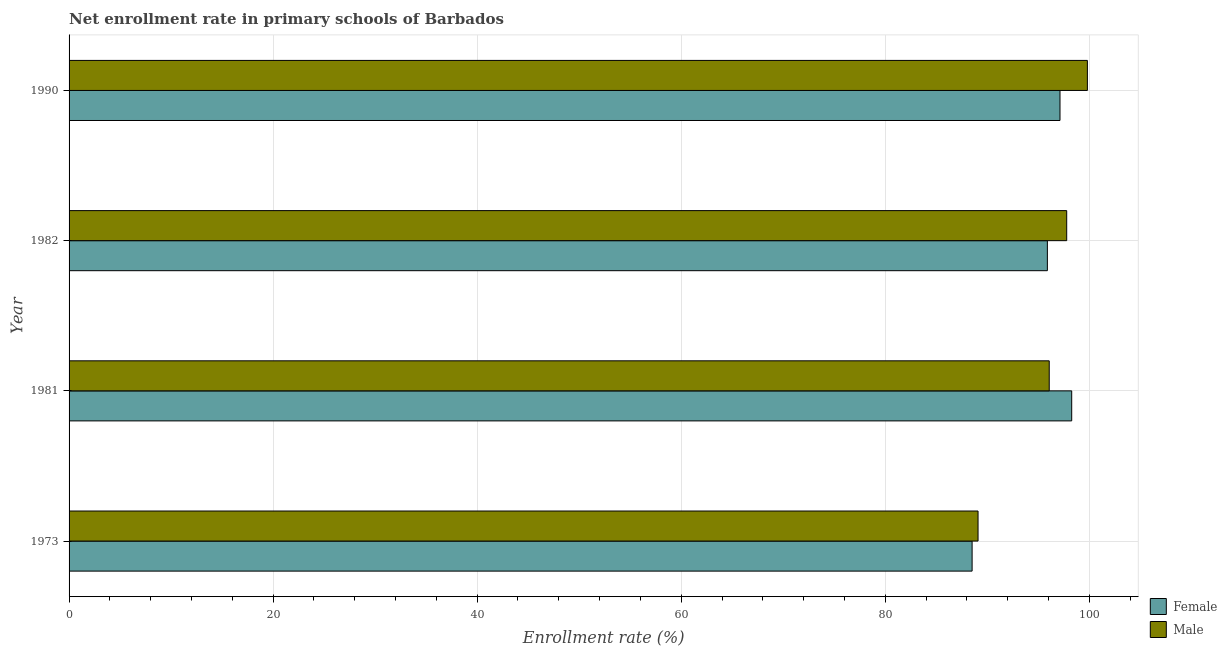Are the number of bars per tick equal to the number of legend labels?
Offer a very short reply. Yes. How many bars are there on the 2nd tick from the top?
Make the answer very short. 2. In how many cases, is the number of bars for a given year not equal to the number of legend labels?
Offer a terse response. 0. What is the enrollment rate of female students in 1973?
Keep it short and to the point. 88.52. Across all years, what is the maximum enrollment rate of female students?
Offer a terse response. 98.28. Across all years, what is the minimum enrollment rate of female students?
Offer a very short reply. 88.52. In which year was the enrollment rate of female students maximum?
Offer a very short reply. 1981. In which year was the enrollment rate of female students minimum?
Ensure brevity in your answer.  1973. What is the total enrollment rate of female students in the graph?
Provide a short and direct response. 379.82. What is the difference between the enrollment rate of female students in 1973 and that in 1982?
Your answer should be very brief. -7.38. What is the difference between the enrollment rate of female students in 1981 and the enrollment rate of male students in 1982?
Make the answer very short. 0.49. What is the average enrollment rate of female students per year?
Give a very brief answer. 94.95. In the year 1973, what is the difference between the enrollment rate of male students and enrollment rate of female students?
Provide a succinct answer. 0.58. In how many years, is the enrollment rate of female students greater than 40 %?
Your response must be concise. 4. Is the enrollment rate of female students in 1981 less than that in 1982?
Your answer should be very brief. No. What is the difference between the highest and the second highest enrollment rate of female students?
Offer a terse response. 1.15. What is the difference between the highest and the lowest enrollment rate of male students?
Offer a very short reply. 10.72. What does the 1st bar from the top in 1982 represents?
Provide a succinct answer. Male. What does the 1st bar from the bottom in 1973 represents?
Offer a very short reply. Female. How many bars are there?
Give a very brief answer. 8. Are all the bars in the graph horizontal?
Offer a terse response. Yes. Are the values on the major ticks of X-axis written in scientific E-notation?
Provide a succinct answer. No. Does the graph contain grids?
Make the answer very short. Yes. How many legend labels are there?
Your response must be concise. 2. How are the legend labels stacked?
Ensure brevity in your answer.  Vertical. What is the title of the graph?
Provide a short and direct response. Net enrollment rate in primary schools of Barbados. What is the label or title of the X-axis?
Your response must be concise. Enrollment rate (%). What is the label or title of the Y-axis?
Ensure brevity in your answer.  Year. What is the Enrollment rate (%) of Female in 1973?
Provide a short and direct response. 88.52. What is the Enrollment rate (%) in Male in 1973?
Offer a very short reply. 89.1. What is the Enrollment rate (%) in Female in 1981?
Your answer should be very brief. 98.28. What is the Enrollment rate (%) in Male in 1981?
Make the answer very short. 96.08. What is the Enrollment rate (%) of Female in 1982?
Your answer should be compact. 95.89. What is the Enrollment rate (%) of Male in 1982?
Your answer should be very brief. 97.79. What is the Enrollment rate (%) of Female in 1990?
Your answer should be very brief. 97.13. What is the Enrollment rate (%) in Male in 1990?
Offer a very short reply. 99.82. Across all years, what is the maximum Enrollment rate (%) in Female?
Your answer should be compact. 98.28. Across all years, what is the maximum Enrollment rate (%) of Male?
Provide a succinct answer. 99.82. Across all years, what is the minimum Enrollment rate (%) in Female?
Your response must be concise. 88.52. Across all years, what is the minimum Enrollment rate (%) of Male?
Give a very brief answer. 89.1. What is the total Enrollment rate (%) of Female in the graph?
Offer a very short reply. 379.82. What is the total Enrollment rate (%) in Male in the graph?
Your answer should be very brief. 382.78. What is the difference between the Enrollment rate (%) in Female in 1973 and that in 1981?
Make the answer very short. -9.76. What is the difference between the Enrollment rate (%) of Male in 1973 and that in 1981?
Keep it short and to the point. -6.98. What is the difference between the Enrollment rate (%) in Female in 1973 and that in 1982?
Give a very brief answer. -7.38. What is the difference between the Enrollment rate (%) in Male in 1973 and that in 1982?
Provide a succinct answer. -8.69. What is the difference between the Enrollment rate (%) of Female in 1973 and that in 1990?
Your answer should be compact. -8.62. What is the difference between the Enrollment rate (%) in Male in 1973 and that in 1990?
Make the answer very short. -10.72. What is the difference between the Enrollment rate (%) in Female in 1981 and that in 1982?
Keep it short and to the point. 2.38. What is the difference between the Enrollment rate (%) of Male in 1981 and that in 1982?
Provide a short and direct response. -1.71. What is the difference between the Enrollment rate (%) of Female in 1981 and that in 1990?
Offer a terse response. 1.15. What is the difference between the Enrollment rate (%) in Male in 1981 and that in 1990?
Make the answer very short. -3.74. What is the difference between the Enrollment rate (%) of Female in 1982 and that in 1990?
Your response must be concise. -1.24. What is the difference between the Enrollment rate (%) of Male in 1982 and that in 1990?
Give a very brief answer. -2.03. What is the difference between the Enrollment rate (%) in Female in 1973 and the Enrollment rate (%) in Male in 1981?
Offer a terse response. -7.56. What is the difference between the Enrollment rate (%) in Female in 1973 and the Enrollment rate (%) in Male in 1982?
Provide a short and direct response. -9.27. What is the difference between the Enrollment rate (%) of Female in 1973 and the Enrollment rate (%) of Male in 1990?
Your answer should be compact. -11.3. What is the difference between the Enrollment rate (%) in Female in 1981 and the Enrollment rate (%) in Male in 1982?
Make the answer very short. 0.49. What is the difference between the Enrollment rate (%) of Female in 1981 and the Enrollment rate (%) of Male in 1990?
Provide a short and direct response. -1.54. What is the difference between the Enrollment rate (%) in Female in 1982 and the Enrollment rate (%) in Male in 1990?
Give a very brief answer. -3.92. What is the average Enrollment rate (%) in Female per year?
Offer a terse response. 94.95. What is the average Enrollment rate (%) of Male per year?
Provide a short and direct response. 95.69. In the year 1973, what is the difference between the Enrollment rate (%) of Female and Enrollment rate (%) of Male?
Your answer should be very brief. -0.58. In the year 1981, what is the difference between the Enrollment rate (%) of Female and Enrollment rate (%) of Male?
Make the answer very short. 2.2. In the year 1982, what is the difference between the Enrollment rate (%) in Female and Enrollment rate (%) in Male?
Your answer should be very brief. -1.89. In the year 1990, what is the difference between the Enrollment rate (%) of Female and Enrollment rate (%) of Male?
Provide a succinct answer. -2.68. What is the ratio of the Enrollment rate (%) of Female in 1973 to that in 1981?
Your answer should be very brief. 0.9. What is the ratio of the Enrollment rate (%) in Male in 1973 to that in 1981?
Offer a terse response. 0.93. What is the ratio of the Enrollment rate (%) in Male in 1973 to that in 1982?
Provide a short and direct response. 0.91. What is the ratio of the Enrollment rate (%) in Female in 1973 to that in 1990?
Ensure brevity in your answer.  0.91. What is the ratio of the Enrollment rate (%) of Male in 1973 to that in 1990?
Provide a short and direct response. 0.89. What is the ratio of the Enrollment rate (%) of Female in 1981 to that in 1982?
Your response must be concise. 1.02. What is the ratio of the Enrollment rate (%) in Male in 1981 to that in 1982?
Give a very brief answer. 0.98. What is the ratio of the Enrollment rate (%) of Female in 1981 to that in 1990?
Provide a short and direct response. 1.01. What is the ratio of the Enrollment rate (%) of Male in 1981 to that in 1990?
Keep it short and to the point. 0.96. What is the ratio of the Enrollment rate (%) of Female in 1982 to that in 1990?
Ensure brevity in your answer.  0.99. What is the ratio of the Enrollment rate (%) in Male in 1982 to that in 1990?
Provide a short and direct response. 0.98. What is the difference between the highest and the second highest Enrollment rate (%) of Female?
Provide a short and direct response. 1.15. What is the difference between the highest and the second highest Enrollment rate (%) in Male?
Offer a very short reply. 2.03. What is the difference between the highest and the lowest Enrollment rate (%) of Female?
Ensure brevity in your answer.  9.76. What is the difference between the highest and the lowest Enrollment rate (%) in Male?
Your answer should be very brief. 10.72. 